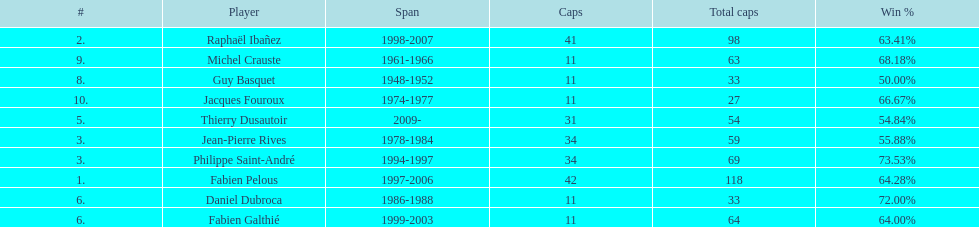How long did michel crauste serve as captain? 1961-1966. 